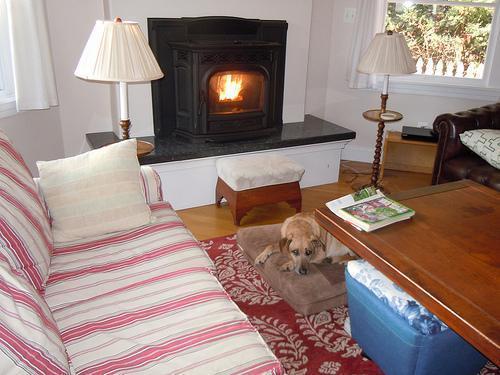How many lamps are in the picture?
Give a very brief answer. 2. 